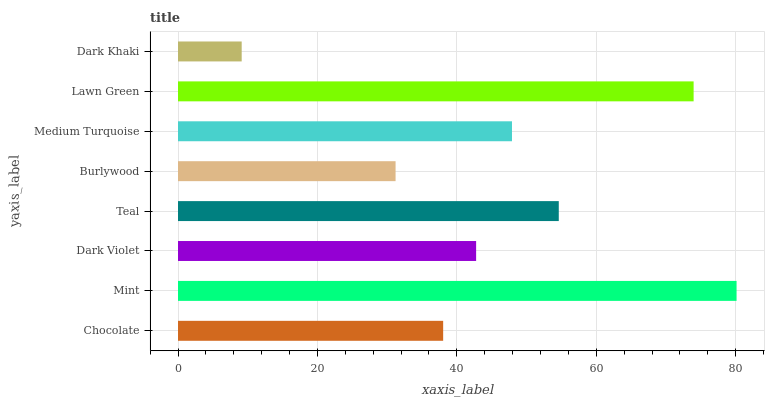Is Dark Khaki the minimum?
Answer yes or no. Yes. Is Mint the maximum?
Answer yes or no. Yes. Is Dark Violet the minimum?
Answer yes or no. No. Is Dark Violet the maximum?
Answer yes or no. No. Is Mint greater than Dark Violet?
Answer yes or no. Yes. Is Dark Violet less than Mint?
Answer yes or no. Yes. Is Dark Violet greater than Mint?
Answer yes or no. No. Is Mint less than Dark Violet?
Answer yes or no. No. Is Medium Turquoise the high median?
Answer yes or no. Yes. Is Dark Violet the low median?
Answer yes or no. Yes. Is Burlywood the high median?
Answer yes or no. No. Is Teal the low median?
Answer yes or no. No. 